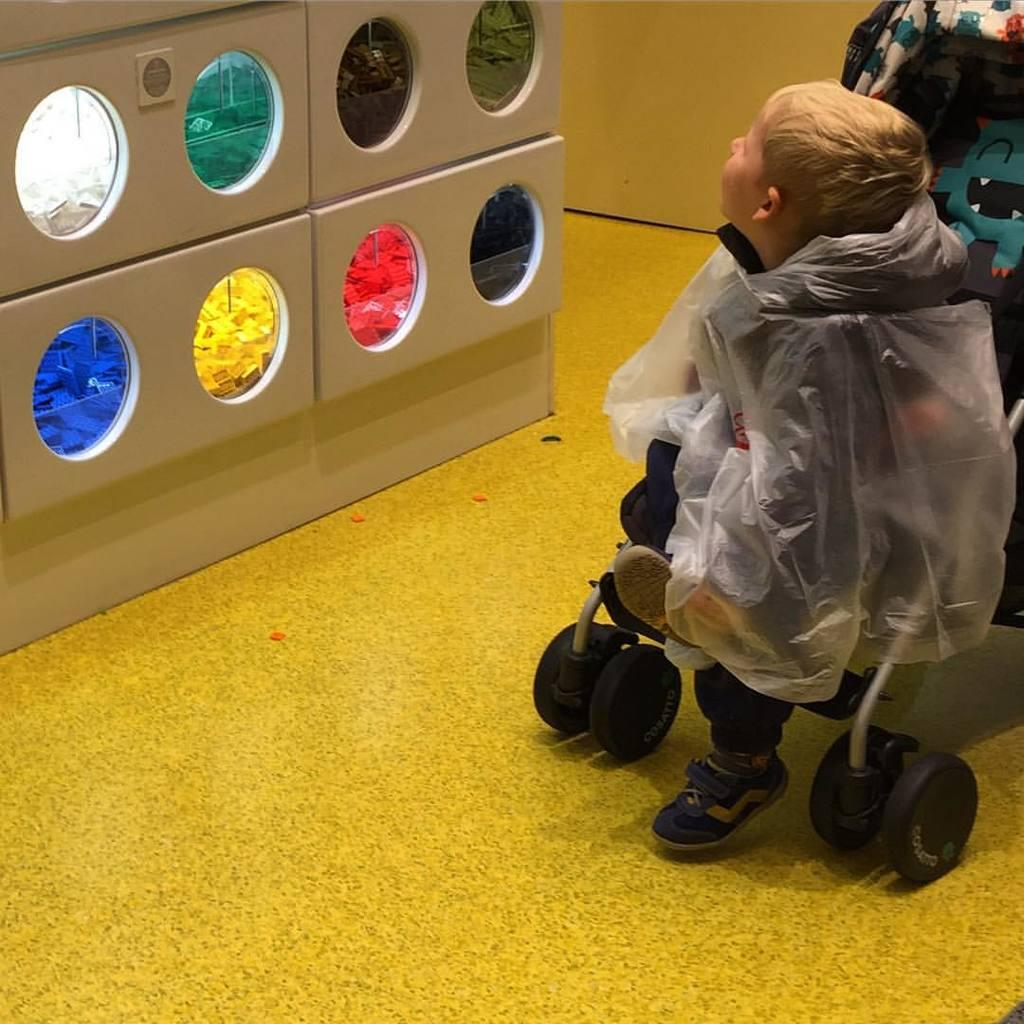What is located on the right side of the image? There is a baby sitting on a stroller on the right side of the image. What can be seen on the left side of the image? There is a machine with different colors and round shapes on the left side of the image. What type of lunch is the baby eating in the image? There is no lunch present in the image; it features a baby sitting on a stroller and a machine with different colors and round shapes. How many houses are visible in the image? There are no houses visible in the image. 